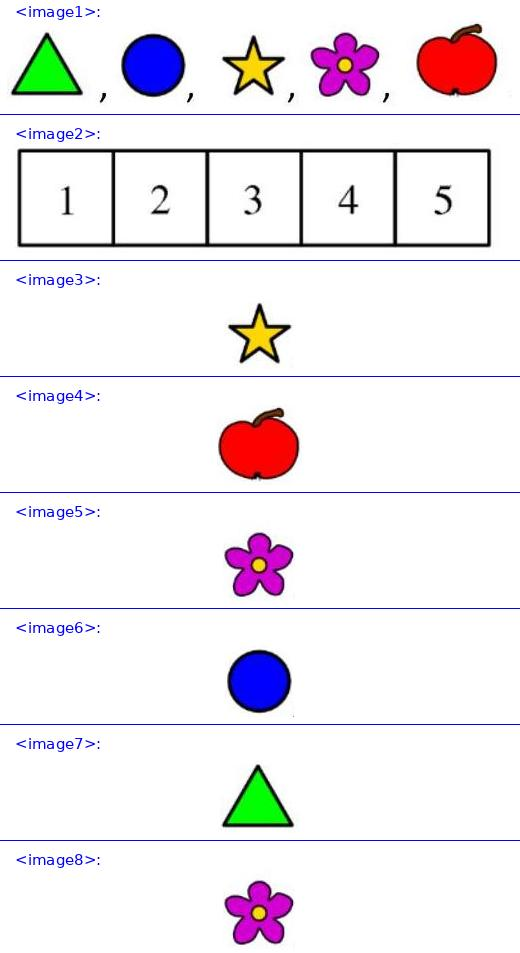<image1> Can you describe what each sticker looks like and what they might symbolize? Certainly! From left to right: The first is a green triangle, often symbolizing growth or stability. Next is a blue circle, which can represent continuity or harmony. The third is a yellow star, usually representing energy or excellence. The fourth sticker is a pink flower, a symbol of beauty and life. Lastly, the red apple, often connected with knowledge or health. 